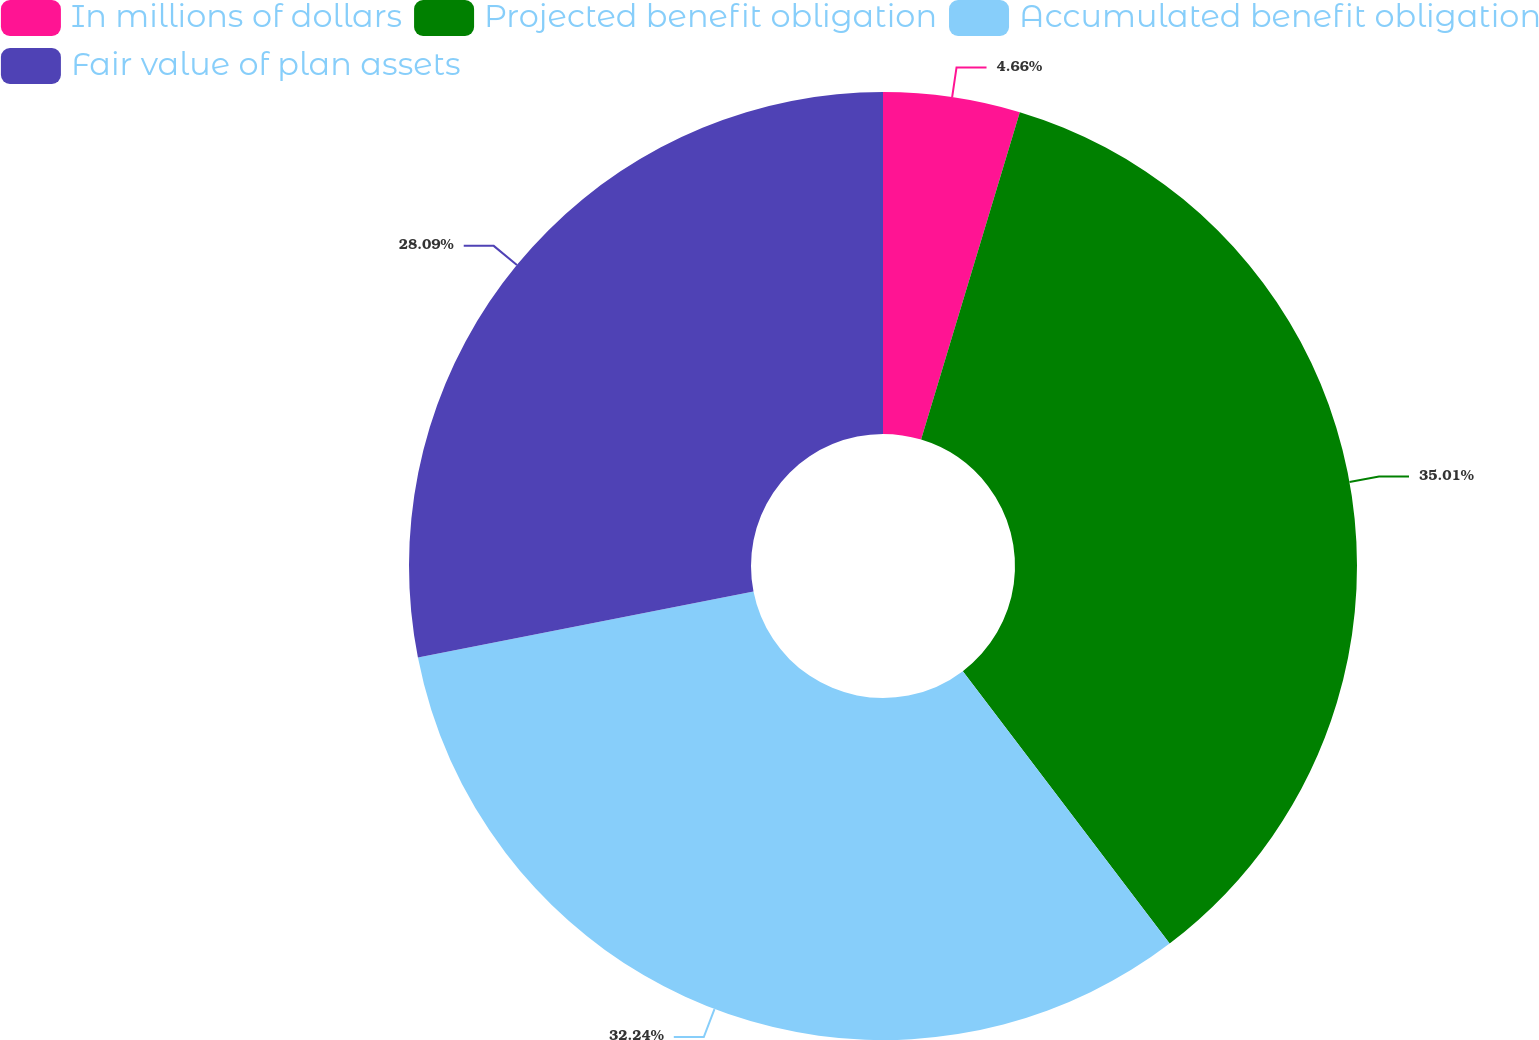Convert chart to OTSL. <chart><loc_0><loc_0><loc_500><loc_500><pie_chart><fcel>In millions of dollars<fcel>Projected benefit obligation<fcel>Accumulated benefit obligation<fcel>Fair value of plan assets<nl><fcel>4.66%<fcel>35.0%<fcel>32.24%<fcel>28.09%<nl></chart> 